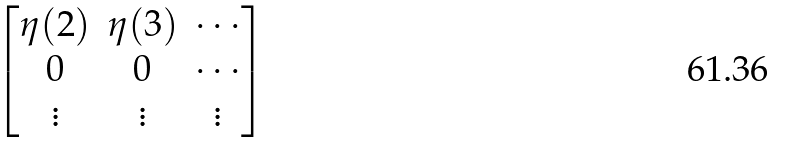Convert formula to latex. <formula><loc_0><loc_0><loc_500><loc_500>\begin{bmatrix} \eta ( 2 ) & \eta ( 3 ) & \cdots \\ 0 & 0 & \cdots \\ \vdots & \vdots & \vdots \end{bmatrix}</formula> 